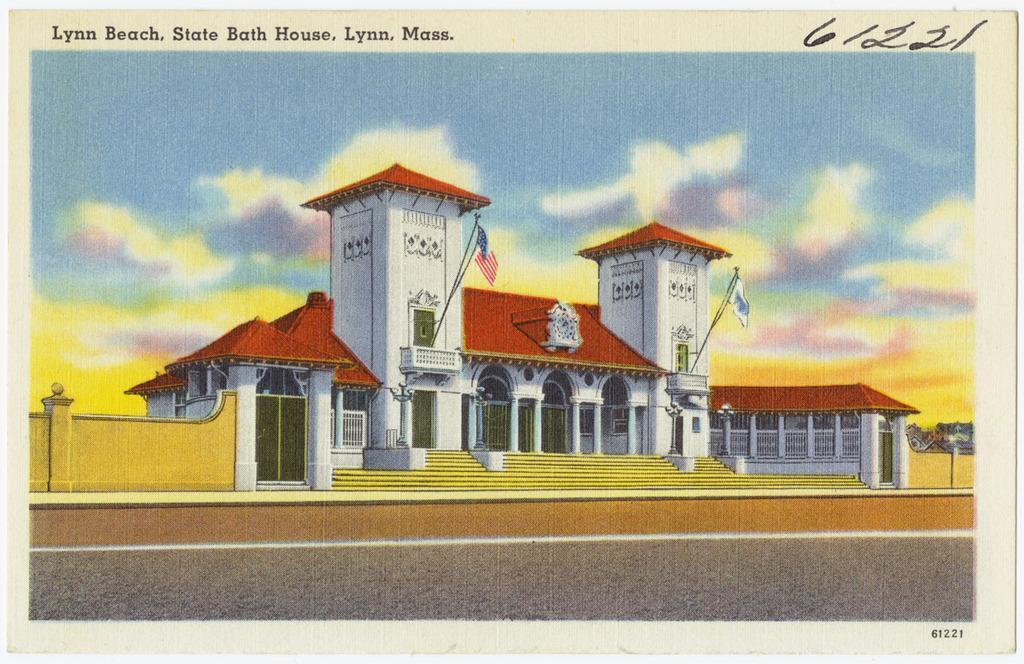Describe this image in one or two sentences. It is a poster. In this image in front there is a road. In the center of the image there is a building. There is a wall. There are flags. In the background of the image there is sky. There is some text on top and bottom of the image. 